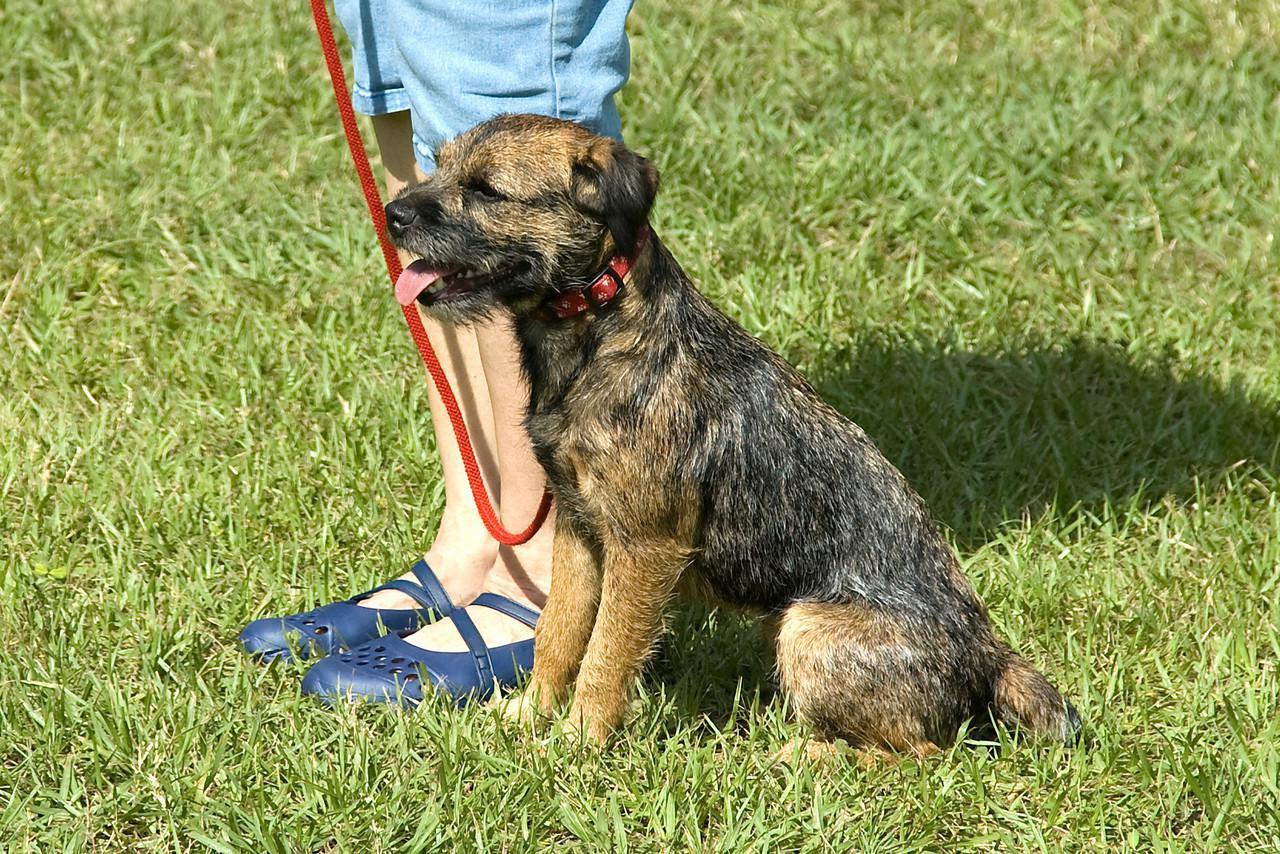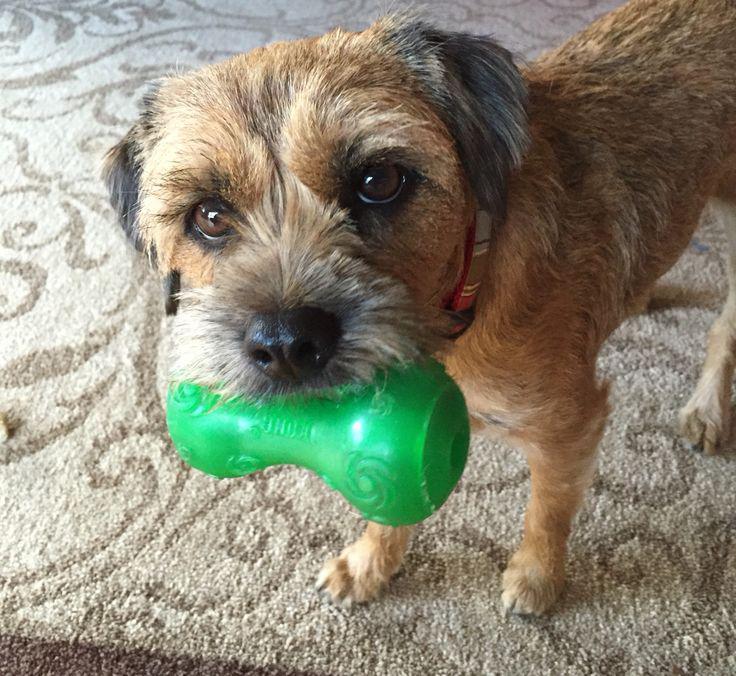The first image is the image on the left, the second image is the image on the right. Analyze the images presented: Is the assertion "There is a dog outside in the grass in the center of both of the images." valid? Answer yes or no. No. The first image is the image on the left, the second image is the image on the right. Assess this claim about the two images: "In both images, there's a border terrier sitting down.". Correct or not? Answer yes or no. No. 